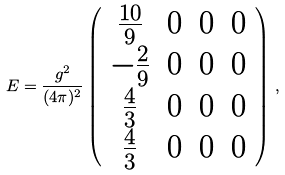<formula> <loc_0><loc_0><loc_500><loc_500>E = \frac { g ^ { 2 } } { ( 4 \pi ) ^ { 2 } } \left ( \begin{array} { c c c c } { { \frac { 1 0 } { 9 } } } & { 0 } & { 0 } & { 0 } \\ { - \frac { 2 } { 9 } } & { 0 } & { 0 } & { 0 } \\ { \frac { 4 } { 3 } } & { 0 } & { 0 } & { 0 } \\ { \frac { 4 } { 3 } } & { 0 } & { 0 } & { 0 } \end{array} \right ) \, ,</formula> 